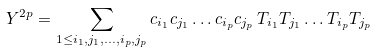Convert formula to latex. <formula><loc_0><loc_0><loc_500><loc_500>Y ^ { 2 p } = \sum _ { 1 \leq i _ { 1 } , j _ { 1 } , \dots , i _ { p } , j _ { p } } { c _ { i _ { 1 } } c _ { j _ { 1 } } \dots c _ { i _ { p } } c _ { j _ { p } } \, T _ { i _ { 1 } } T _ { j _ { 1 } } \dots T _ { i _ { p } } T _ { j _ { p } } }</formula> 